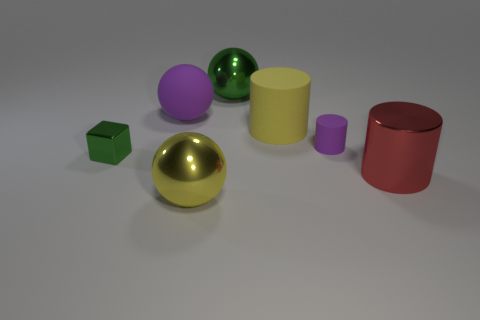Subtract all large shiny spheres. How many spheres are left? 1 Subtract 1 cylinders. How many cylinders are left? 2 Add 1 big metal objects. How many objects exist? 8 Subtract all spheres. How many objects are left? 4 Subtract all brown cylinders. Subtract all purple cubes. How many cylinders are left? 3 Add 7 small cyan metallic cylinders. How many small cyan metallic cylinders exist? 7 Subtract 0 gray cylinders. How many objects are left? 7 Subtract all green metallic balls. Subtract all large red cylinders. How many objects are left? 5 Add 1 big yellow matte things. How many big yellow matte things are left? 2 